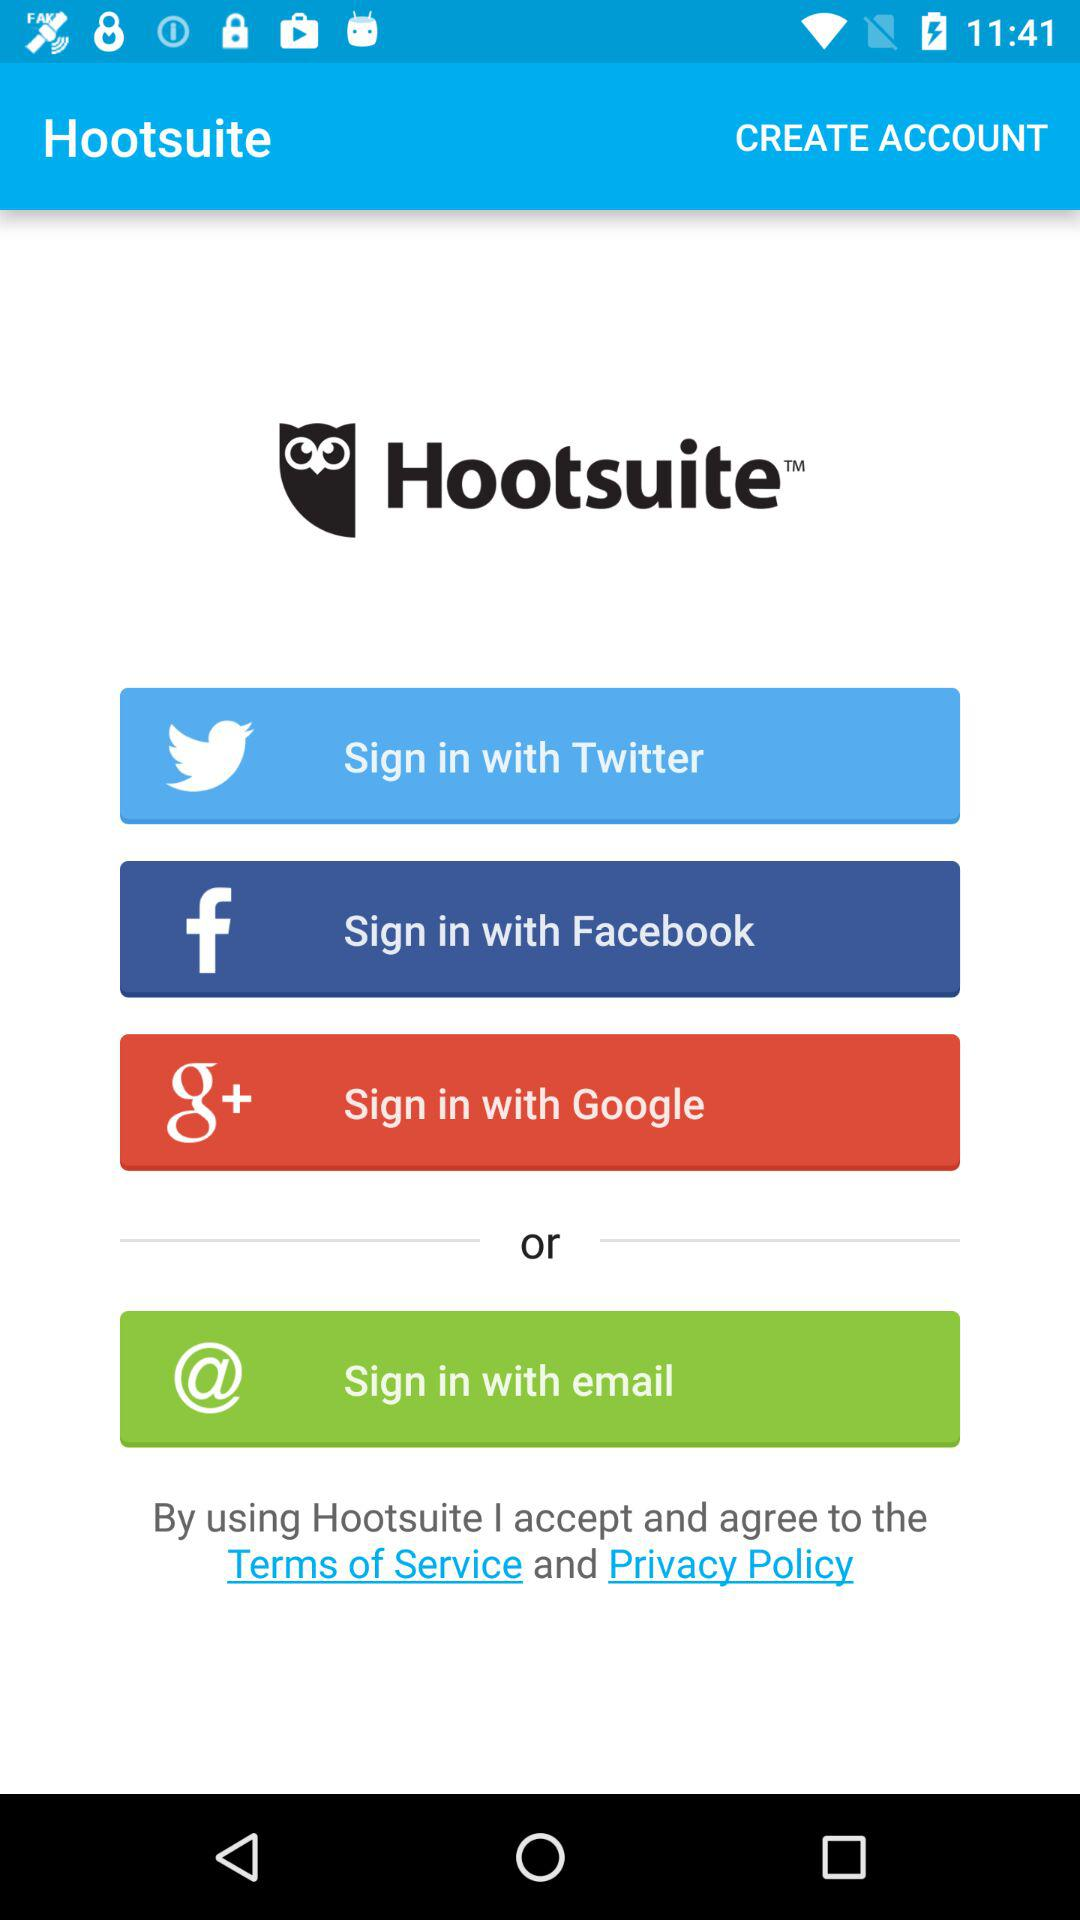Has the user agreed to the terms of service and privacy policy?
When the provided information is insufficient, respond with <no answer>. <no answer> 